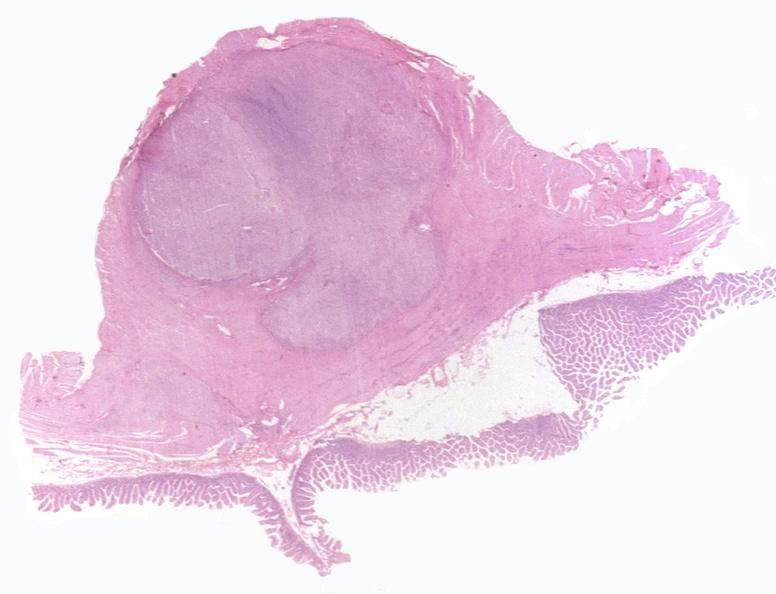does fetus developing very early show intestine, leiomyoma?
Answer the question using a single word or phrase. No 